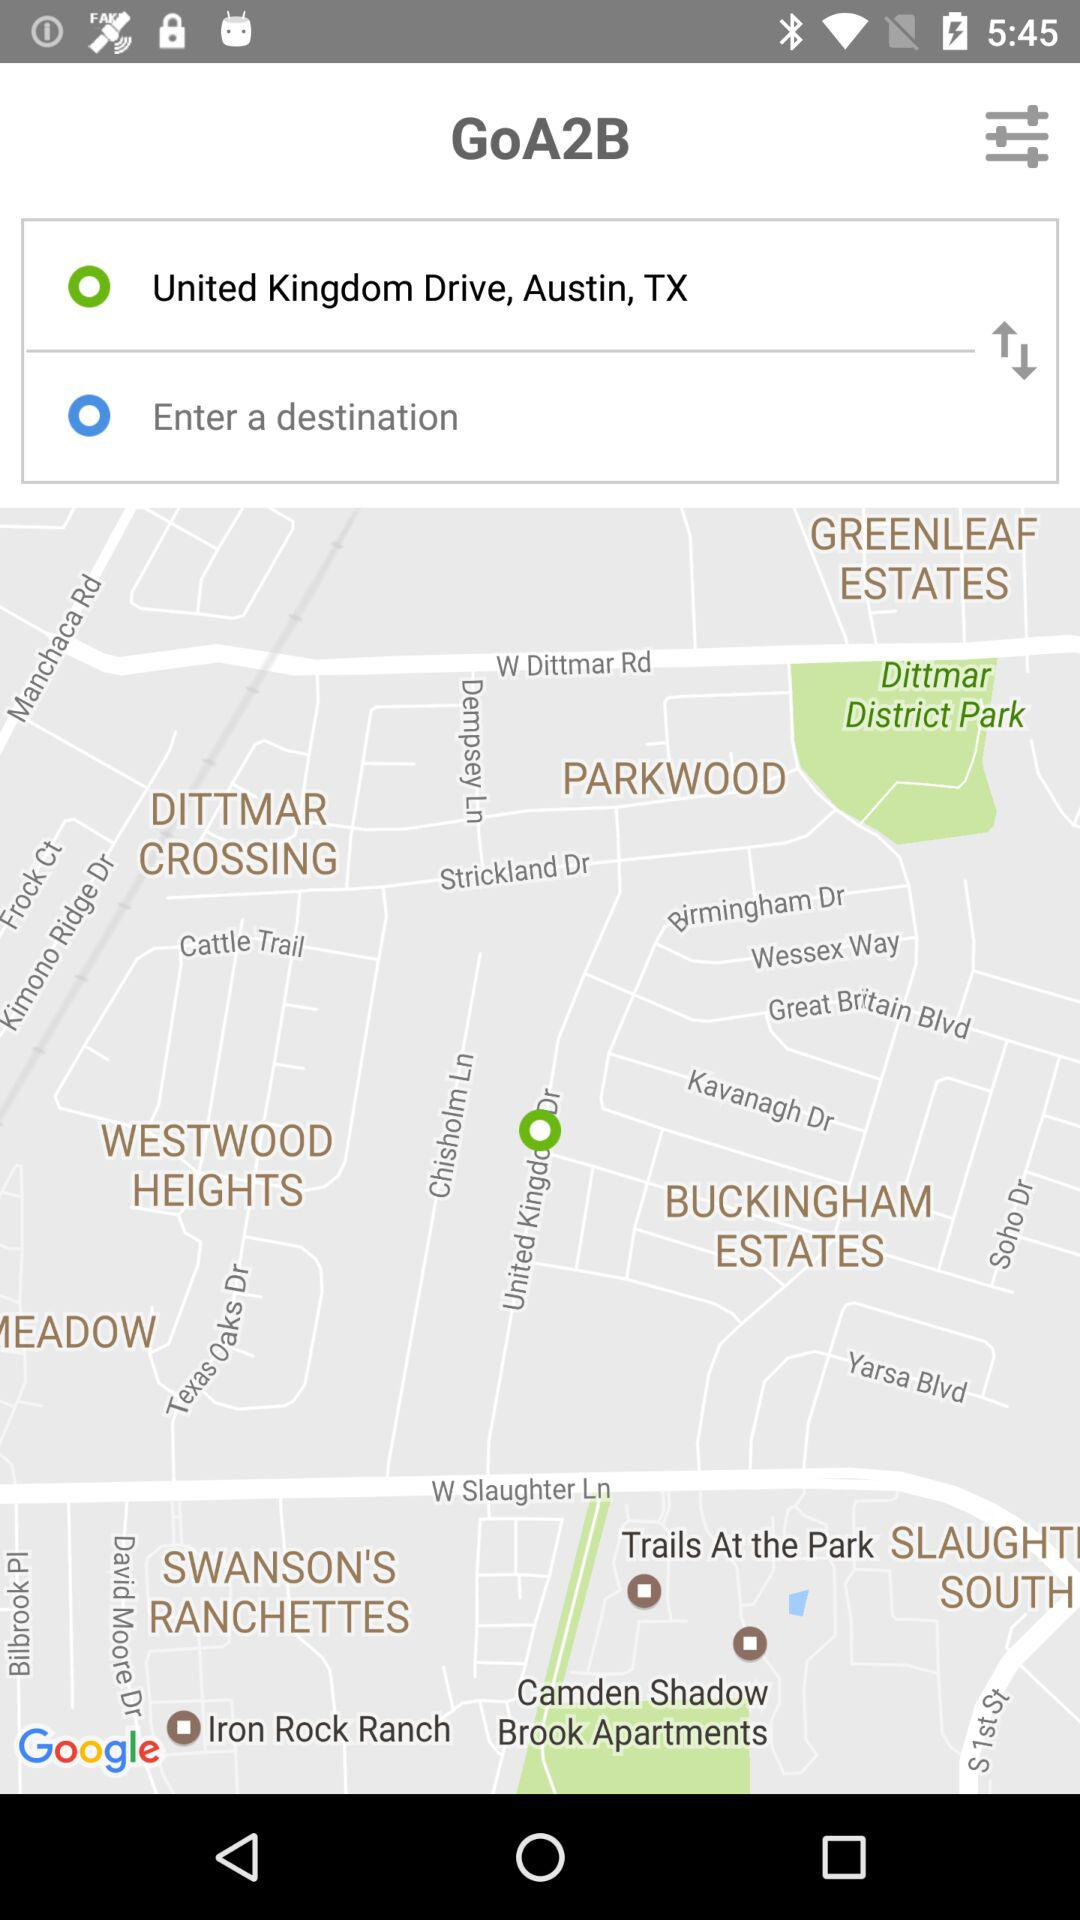What is the application name? The application name is "GoA2B". 